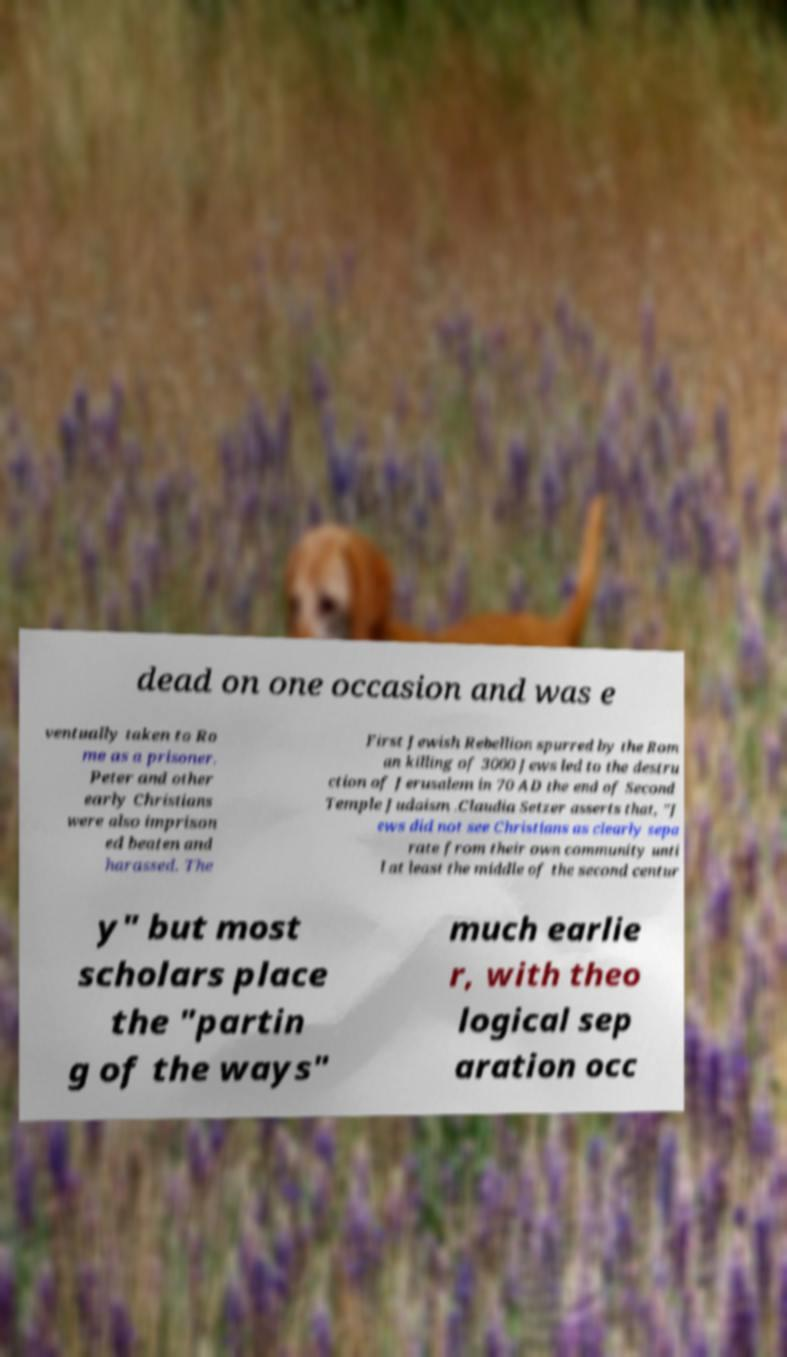Can you accurately transcribe the text from the provided image for me? dead on one occasion and was e ventually taken to Ro me as a prisoner. Peter and other early Christians were also imprison ed beaten and harassed. The First Jewish Rebellion spurred by the Rom an killing of 3000 Jews led to the destru ction of Jerusalem in 70 AD the end of Second Temple Judaism .Claudia Setzer asserts that, "J ews did not see Christians as clearly sepa rate from their own community unti l at least the middle of the second centur y" but most scholars place the "partin g of the ways" much earlie r, with theo logical sep aration occ 